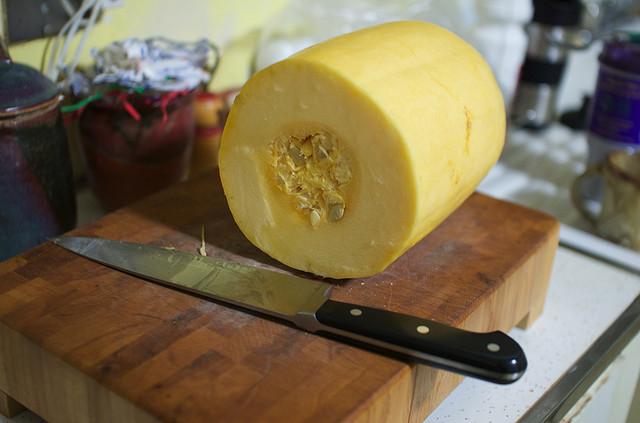What is the cutting block made of?
Answer briefly. Wood. Is there a knife in the picture?
Quick response, please. Yes. Is the squash cut?
Answer briefly. Yes. What is this tool?
Concise answer only. Knife. 